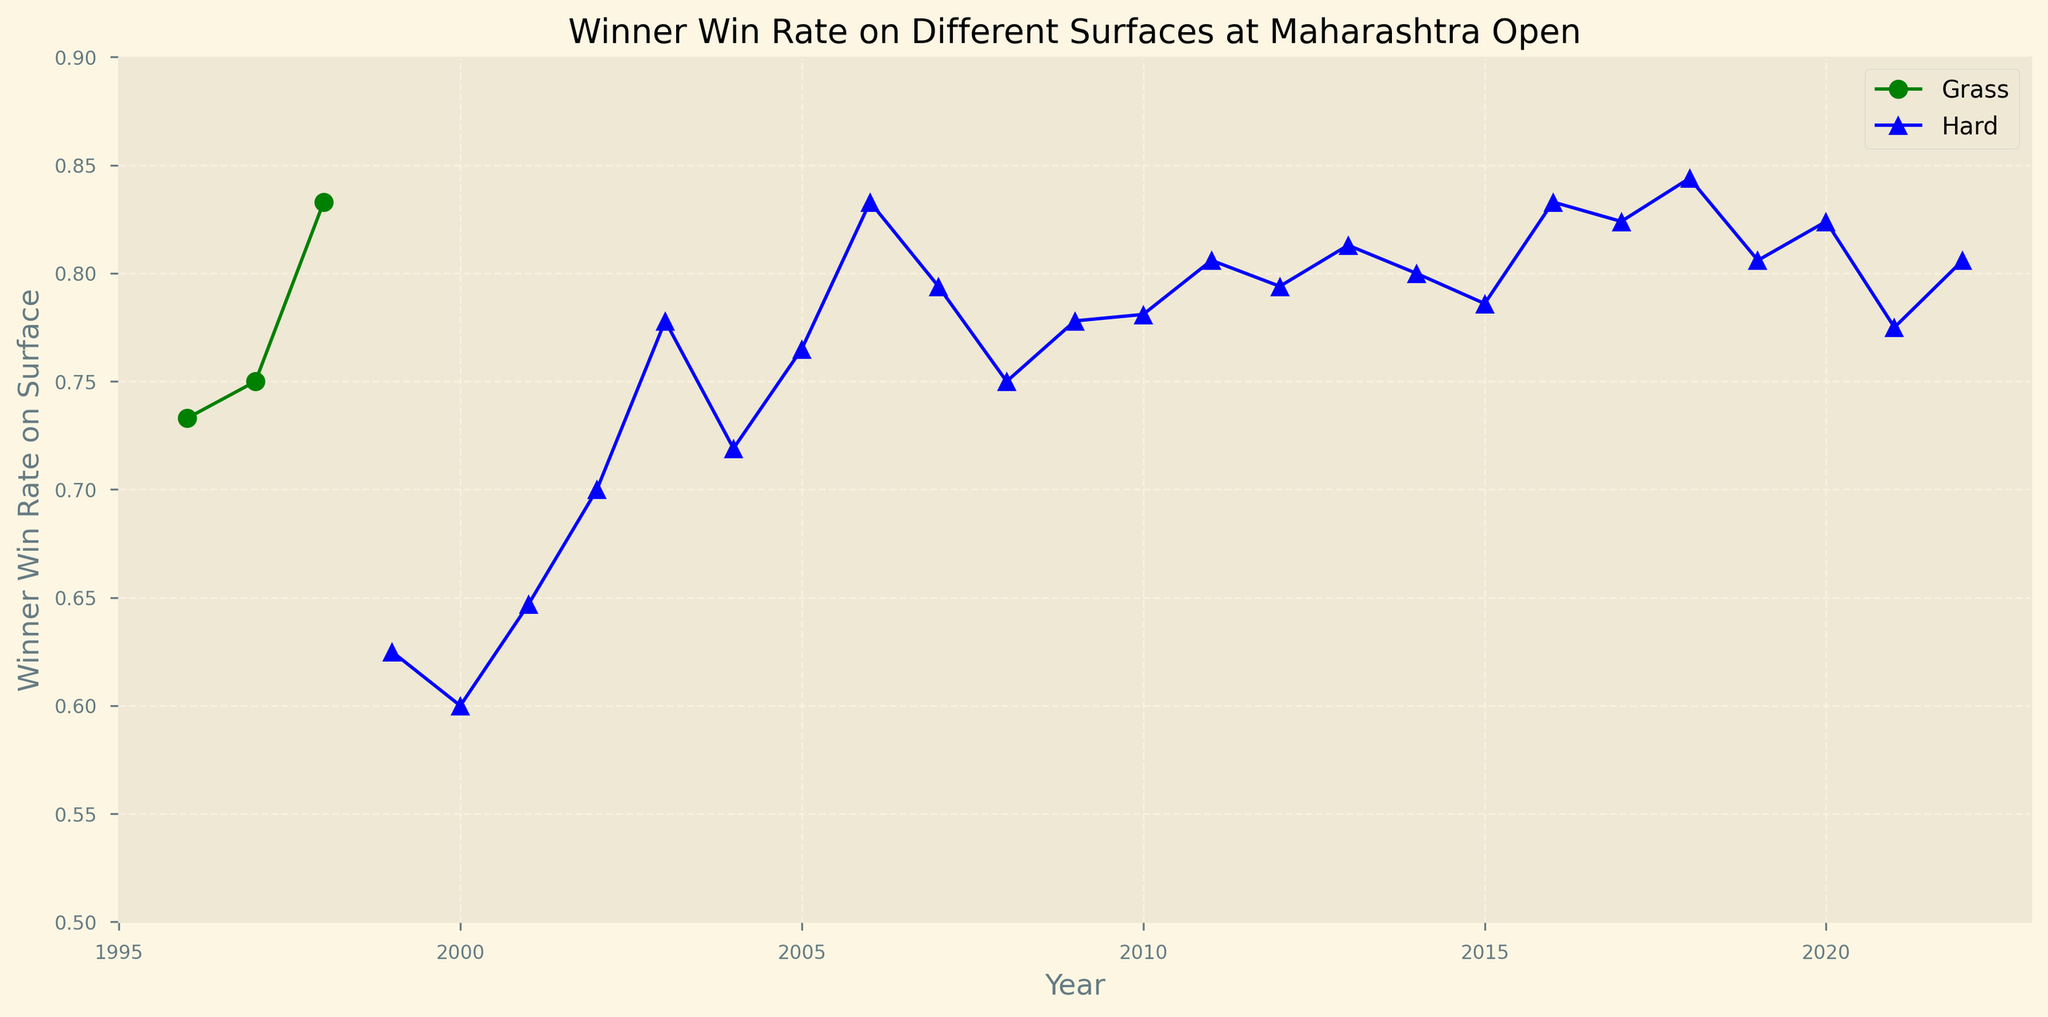What was the Winner Win Rate on Grass in 1998? Look at the point marked with an 'o' for the year 1998 in the figure, which represents grass. The y-axis value indicates the Winner Win Rate.
Answer: 0.833 In what year did the surface change from grass to hard? Identify the last year where 'Grass' is indicated in the legend and the subsequent year where 'Hard' appears. The last grass year is 1998 and the first hard year is 1999.
Answer: 1999 Which surface type had a higher maximum Winner Win Rate overall? Compare the highest points for Grass and Hard lines. Grass's highest is 0.833, but Hard reaches up to 0.844.
Answer: Hard What is the average Winner Win Rate for Hard surfaces between 2010 and 2015? Find the values for Hard surfaces from 2010 to 2015 and calculate the average: (0.781 + 0.806 + 0.794 + 0.813 + 0.800 + 0.786) / 6 = 0.7967.
Answer: 0.7967 Was there any year where the Winner Win Rate was the same for both surface types? Check if any y-axis values (Winner Win Rate) for Grass and Hard lines are identical by visual comparison. There is no such year.
Answer: No Which year showed the lowest Winner Win Rate on Hard courts? Identify the lowest point on the Hard court line. The minimum value is 0.600 in the year 2000.
Answer: 2000 How did the Winner Win Rate on Grass in 1996 compare to Hard in 2022? Look at the Winner Win Rate for Grass in 1996 (0.733) and Hard in 2022 (0.806), then compare.
Answer: Hard in 2022 was higher What is the difference in Winner Win Rates between the highest Grass year and lowest Hard year? The highest Grass rate was 0.833 (1998), and the lowest Hard rate was 0.600 (2000). Calculate the difference: 0.833 - 0.600 = 0.233.
Answer: 0.233 During which periods did the Winner Win Rate on Hard courts consistently rise without a decrease? Find continuous upward trends without any decline for Hard courts. From 2001 (0.647) to 2003 (0.778), and from 2017 (0.824) to 2018 (0.844).
Answer: 2001-2003, 2017-2018 How many years did the Winner Win Rate on Hard courts exceed 0.800? Count the yearly data points on the Hard line where the value exceeds 0.800. There are 11 years: 2011-2013, 2014-2019, 2020, 2022.
Answer: 11 